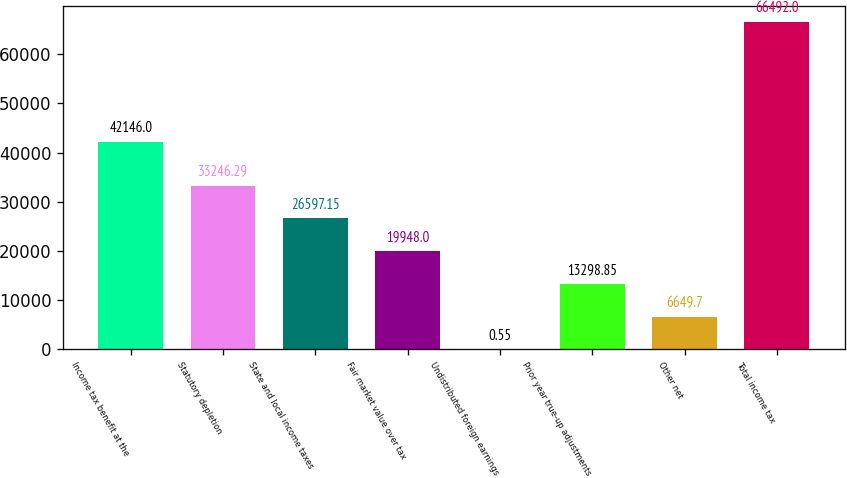<chart> <loc_0><loc_0><loc_500><loc_500><bar_chart><fcel>Income tax benefit at the<fcel>Statutory depletion<fcel>State and local income taxes<fcel>Fair market value over tax<fcel>Undistributed foreign earnings<fcel>Prior year true-up adjustments<fcel>Other net<fcel>Total income tax<nl><fcel>42146<fcel>33246.3<fcel>26597.2<fcel>19948<fcel>0.55<fcel>13298.9<fcel>6649.7<fcel>66492<nl></chart> 